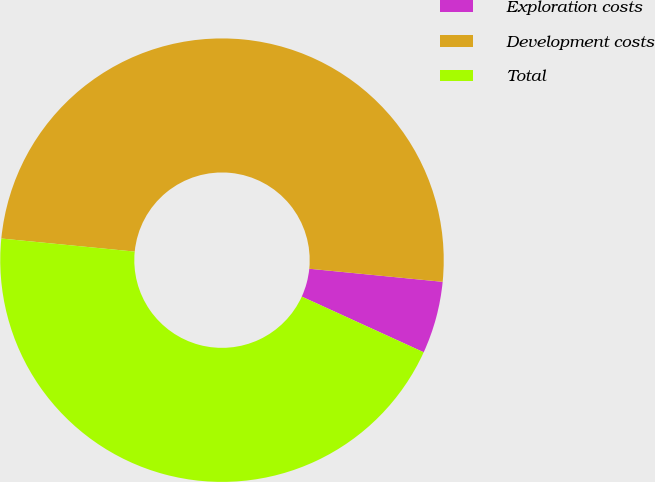<chart> <loc_0><loc_0><loc_500><loc_500><pie_chart><fcel>Exploration costs<fcel>Development costs<fcel>Total<nl><fcel>5.26%<fcel>50.0%<fcel>44.74%<nl></chart> 